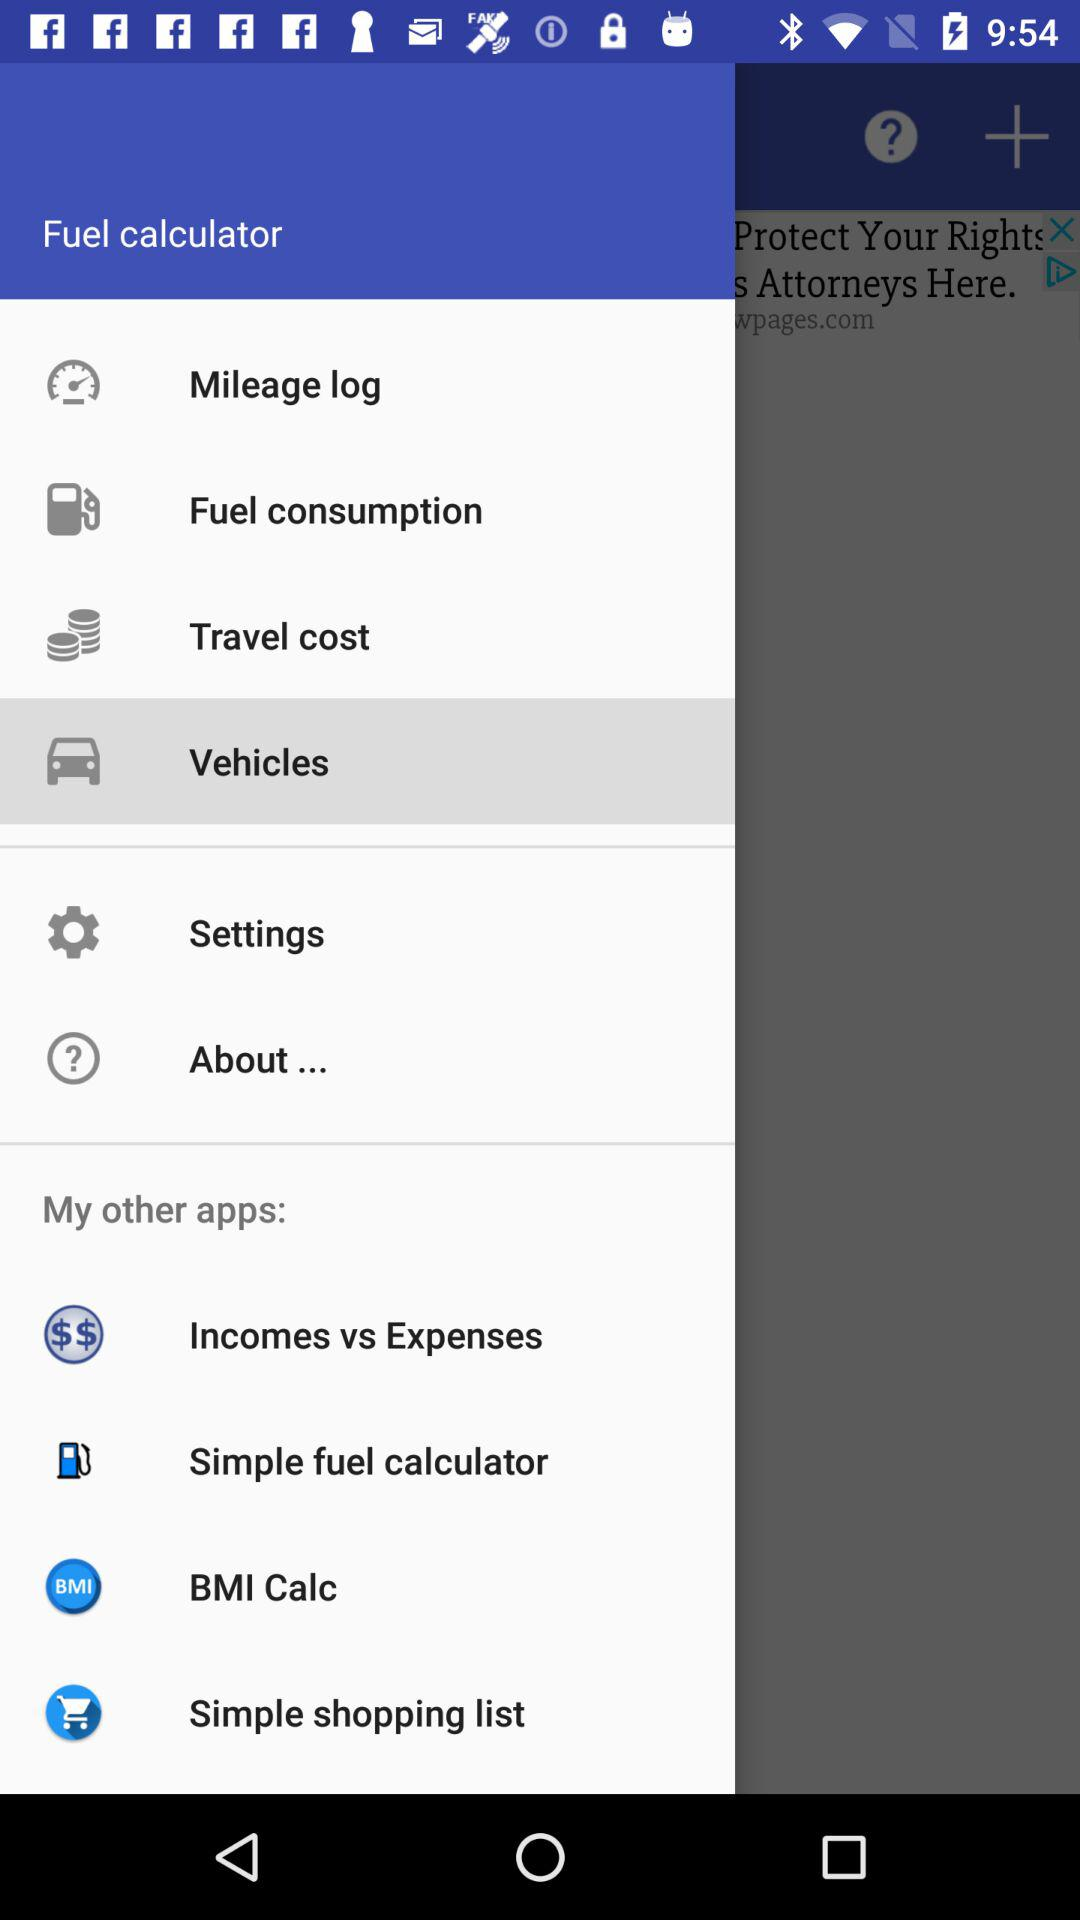What is the application name? The application name is "Fuel calculator". 